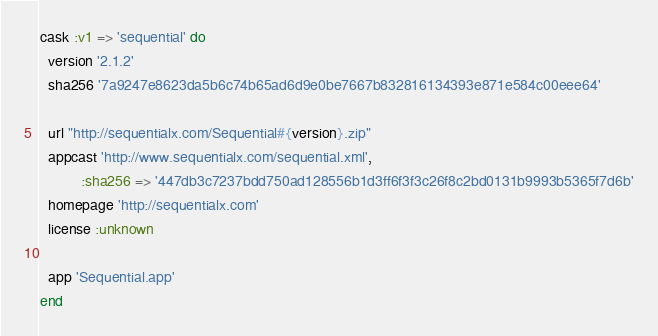<code> <loc_0><loc_0><loc_500><loc_500><_Ruby_>cask :v1 => 'sequential' do
  version '2.1.2'
  sha256 '7a9247e8623da5b6c74b65ad6d9e0be7667b832816134393e871e584c00eee64'

  url "http://sequentialx.com/Sequential#{version}.zip"
  appcast 'http://www.sequentialx.com/sequential.xml',
          :sha256 => '447db3c7237bdd750ad128556b1d3ff6f3f3c26f8c2bd0131b9993b5365f7d6b'
  homepage 'http://sequentialx.com'
  license :unknown

  app 'Sequential.app'
end
</code> 